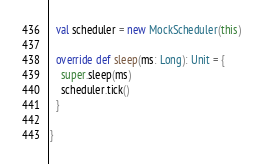<code> <loc_0><loc_0><loc_500><loc_500><_Scala_>  val scheduler = new MockScheduler(this)

  override def sleep(ms: Long): Unit = {
    super.sleep(ms)
    scheduler.tick()
  }

}
</code> 